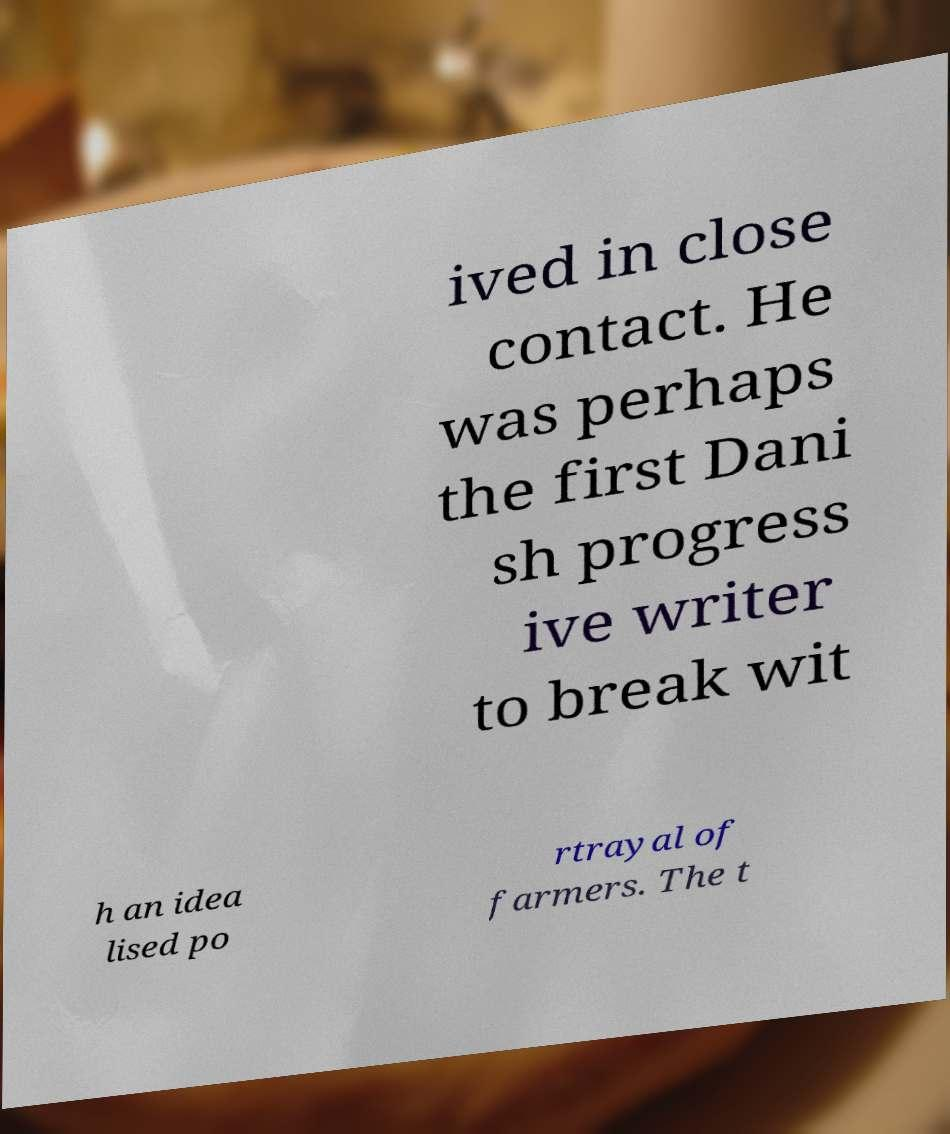Can you read and provide the text displayed in the image?This photo seems to have some interesting text. Can you extract and type it out for me? ived in close contact. He was perhaps the first Dani sh progress ive writer to break wit h an idea lised po rtrayal of farmers. The t 